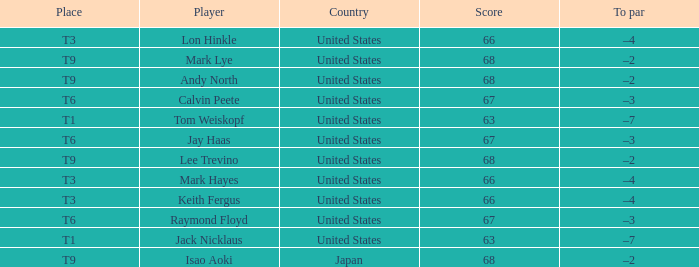What is To Par, when Place is "T9", and when Player is "Lee Trevino"? –2. 